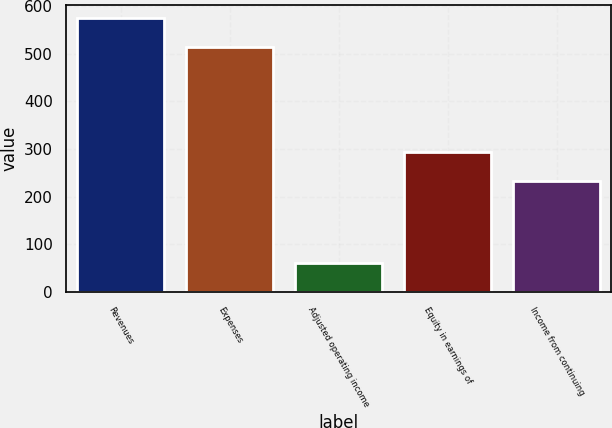<chart> <loc_0><loc_0><loc_500><loc_500><bar_chart><fcel>Revenues<fcel>Expenses<fcel>Adjusted operating income<fcel>Equity in earnings of<fcel>Income from continuing<nl><fcel>574<fcel>513<fcel>61<fcel>294<fcel>233<nl></chart> 